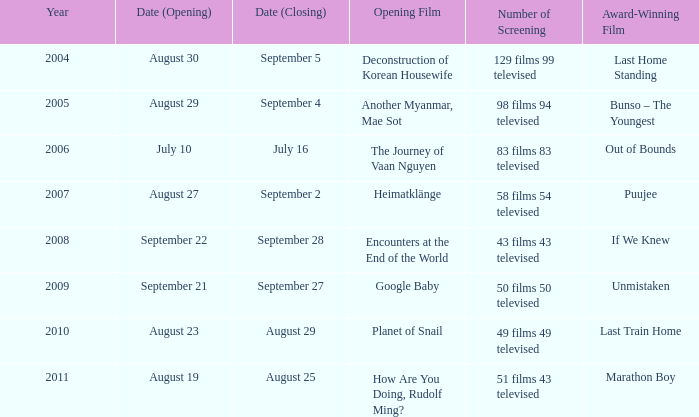Which opening film has the opening date of august 23? Planet of Snail. 